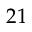<formula> <loc_0><loc_0><loc_500><loc_500>2 1</formula> 